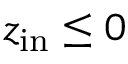Convert formula to latex. <formula><loc_0><loc_0><loc_500><loc_500>z _ { i n } \leq 0</formula> 